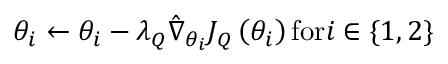Convert formula to latex. <formula><loc_0><loc_0><loc_500><loc_500>{ \theta _ { i } } \leftarrow { \theta _ { i } } - { \lambda _ { Q } } { \hat { \nabla } _ { { \theta _ { i } } } } { J _ { Q } } \left ( { { \theta _ { i } } } \right ) { f o r } i \in \{ 1 , 2</formula> 